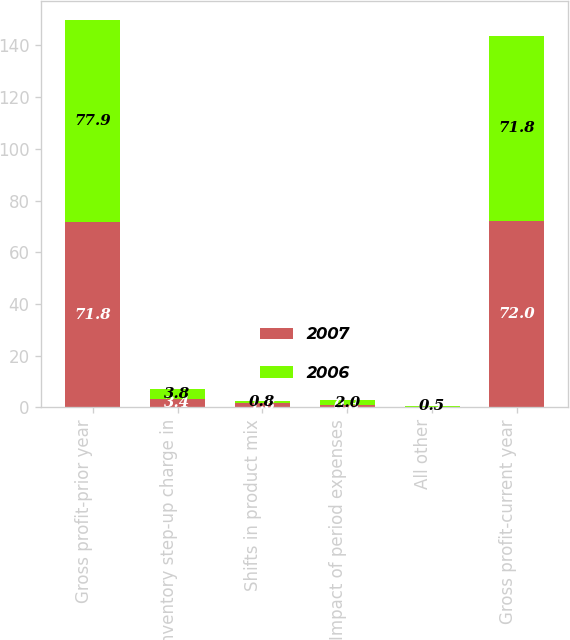<chart> <loc_0><loc_0><loc_500><loc_500><stacked_bar_chart><ecel><fcel>Gross profit-prior year<fcel>Inventory step-up charge in<fcel>Shifts in product mix<fcel>Impact of period expenses<fcel>All other<fcel>Gross profit-current year<nl><fcel>2007<fcel>71.8<fcel>3.4<fcel>1.8<fcel>0.8<fcel>0.2<fcel>72<nl><fcel>2006<fcel>77.9<fcel>3.8<fcel>0.8<fcel>2<fcel>0.5<fcel>71.8<nl></chart> 